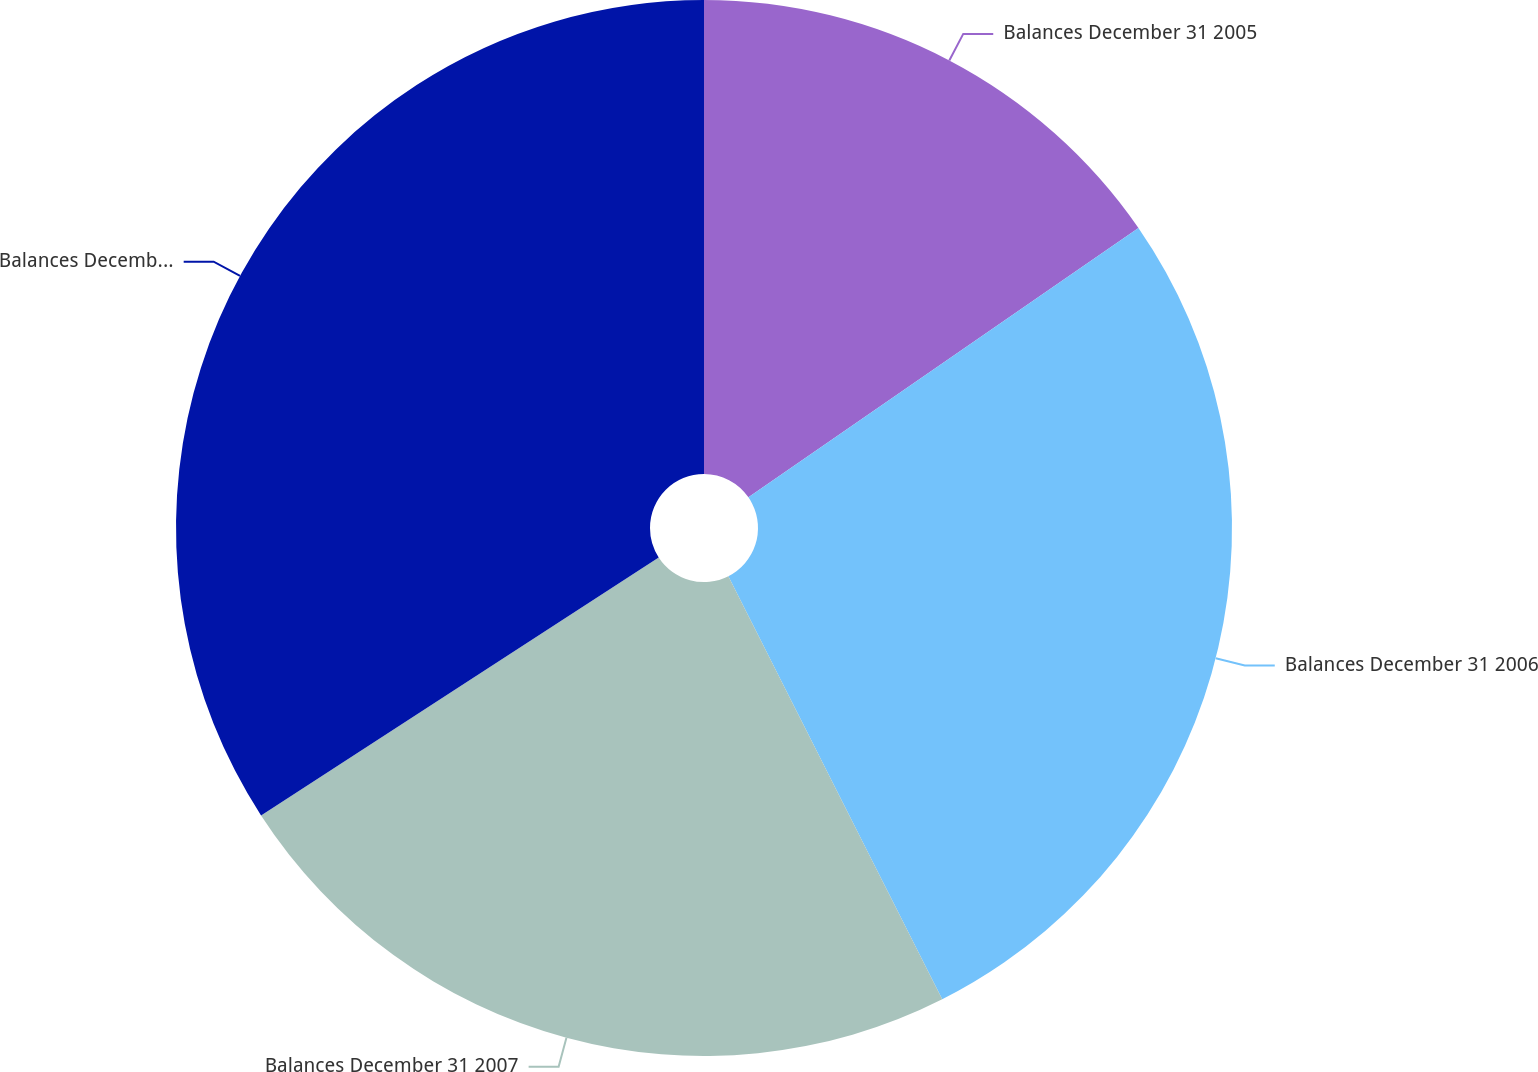Convert chart to OTSL. <chart><loc_0><loc_0><loc_500><loc_500><pie_chart><fcel>Balances December 31 2005<fcel>Balances December 31 2006<fcel>Balances December 31 2007<fcel>Balances December 31 2008<nl><fcel>15.38%<fcel>27.17%<fcel>23.29%<fcel>34.16%<nl></chart> 